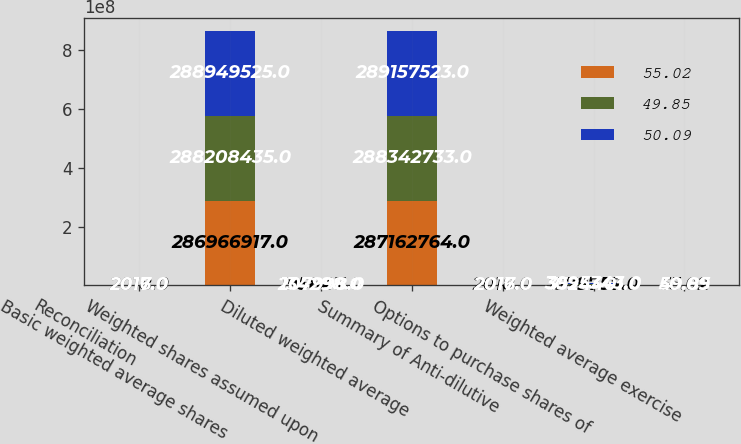<chart> <loc_0><loc_0><loc_500><loc_500><stacked_bar_chart><ecel><fcel>Reconciliation<fcel>Basic weighted average shares<fcel>Weighted shares assumed upon<fcel>Diluted weighted average<fcel>Summary of Anti-dilutive<fcel>Options to purchase shares of<fcel>Weighted average exercise<nl><fcel>55.02<fcel>2018<fcel>2.86967e+08<fcel>195847<fcel>2.87163e+08<fcel>2018<fcel>1.57976e+06<fcel>55.02<nl><fcel>49.85<fcel>2017<fcel>2.88208e+08<fcel>134298<fcel>2.88343e+08<fcel>2017<fcel>3.5244e+06<fcel>49.85<nl><fcel>50.09<fcel>2016<fcel>2.8895e+08<fcel>207998<fcel>2.89158e+08<fcel>2016<fcel>3.09534e+06<fcel>50.09<nl></chart> 